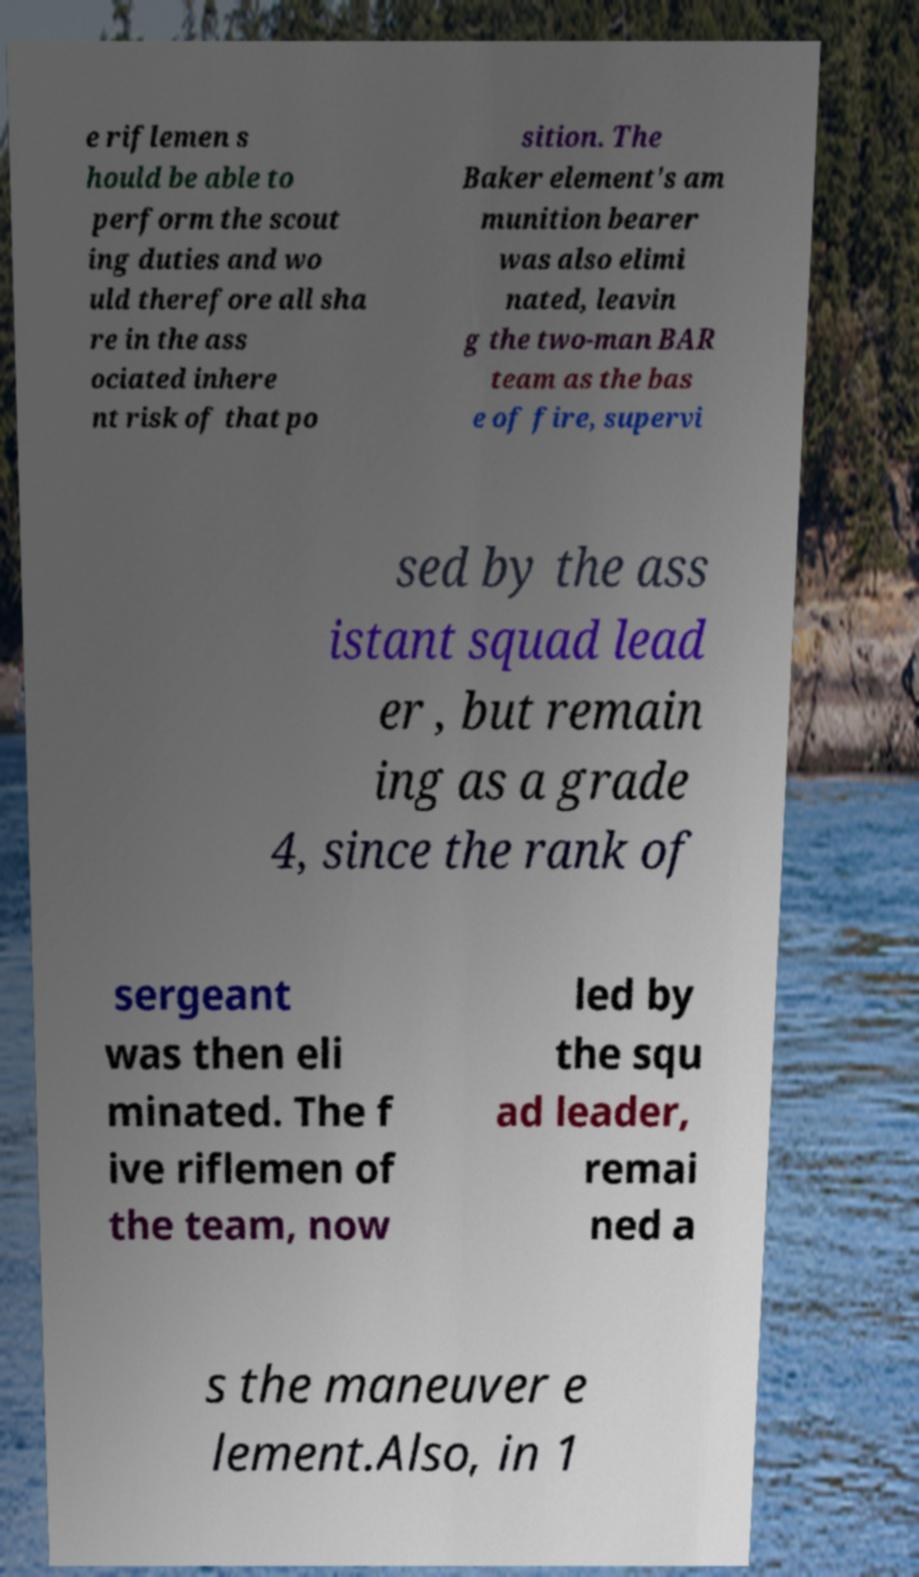I need the written content from this picture converted into text. Can you do that? e riflemen s hould be able to perform the scout ing duties and wo uld therefore all sha re in the ass ociated inhere nt risk of that po sition. The Baker element's am munition bearer was also elimi nated, leavin g the two-man BAR team as the bas e of fire, supervi sed by the ass istant squad lead er , but remain ing as a grade 4, since the rank of sergeant was then eli minated. The f ive riflemen of the team, now led by the squ ad leader, remai ned a s the maneuver e lement.Also, in 1 